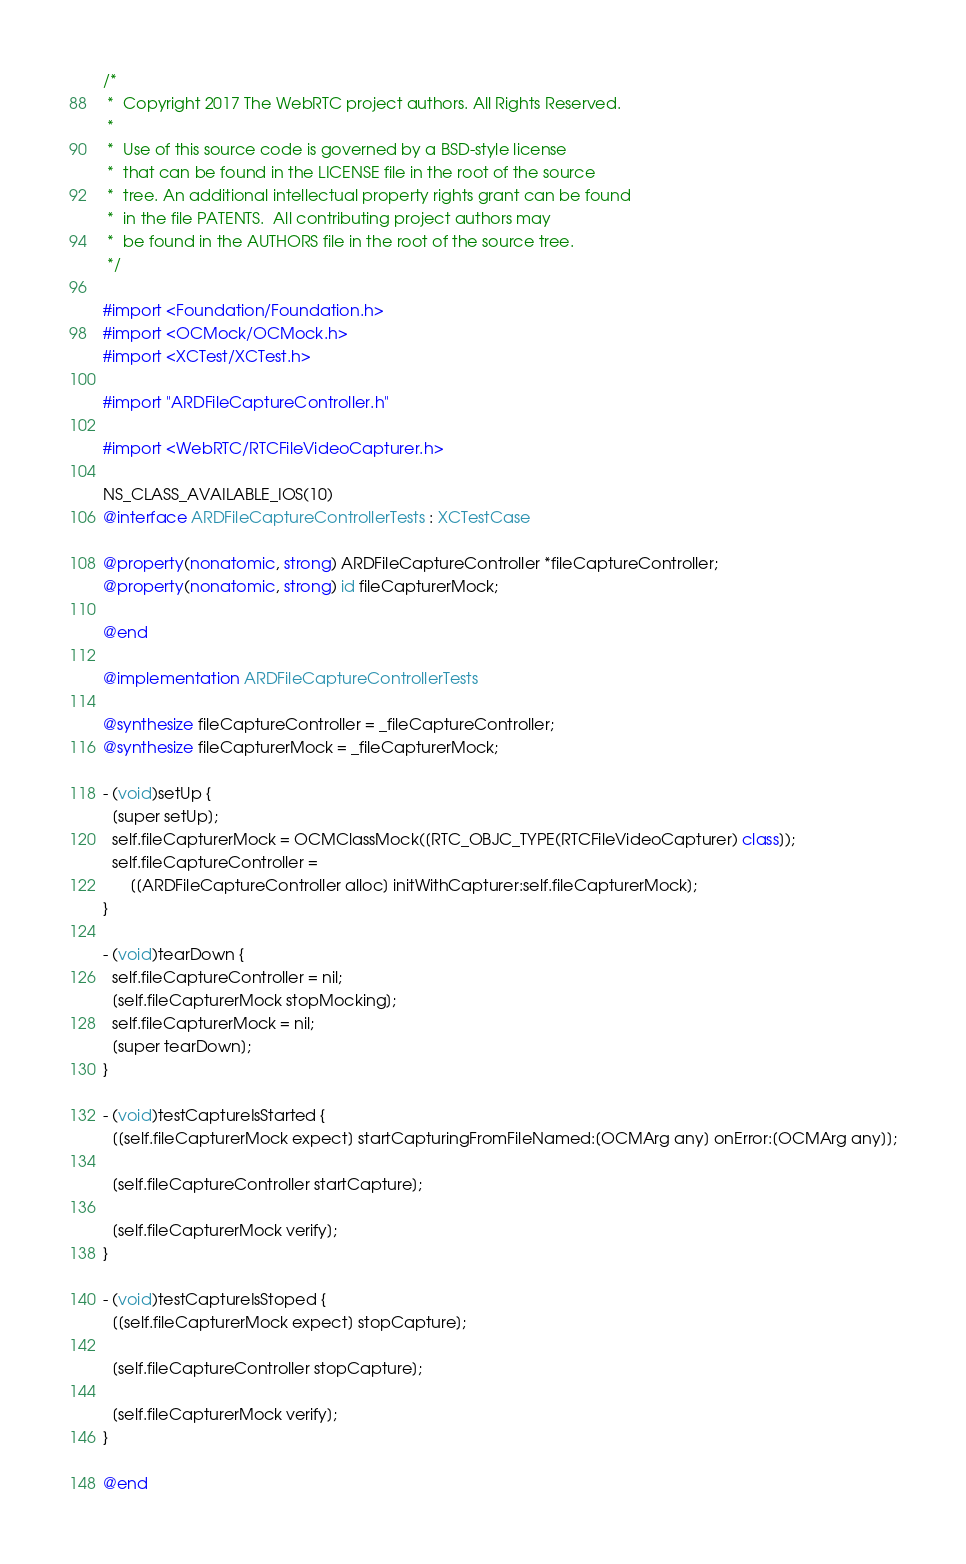Convert code to text. <code><loc_0><loc_0><loc_500><loc_500><_ObjectiveC_>/*
 *  Copyright 2017 The WebRTC project authors. All Rights Reserved.
 *
 *  Use of this source code is governed by a BSD-style license
 *  that can be found in the LICENSE file in the root of the source
 *  tree. An additional intellectual property rights grant can be found
 *  in the file PATENTS.  All contributing project authors may
 *  be found in the AUTHORS file in the root of the source tree.
 */

#import <Foundation/Foundation.h>
#import <OCMock/OCMock.h>
#import <XCTest/XCTest.h>

#import "ARDFileCaptureController.h"

#import <WebRTC/RTCFileVideoCapturer.h>

NS_CLASS_AVAILABLE_IOS(10)
@interface ARDFileCaptureControllerTests : XCTestCase

@property(nonatomic, strong) ARDFileCaptureController *fileCaptureController;
@property(nonatomic, strong) id fileCapturerMock;

@end

@implementation ARDFileCaptureControllerTests

@synthesize fileCaptureController = _fileCaptureController;
@synthesize fileCapturerMock = _fileCapturerMock;

- (void)setUp {
  [super setUp];
  self.fileCapturerMock = OCMClassMock([RTC_OBJC_TYPE(RTCFileVideoCapturer) class]);
  self.fileCaptureController =
      [[ARDFileCaptureController alloc] initWithCapturer:self.fileCapturerMock];
}

- (void)tearDown {
  self.fileCaptureController = nil;
  [self.fileCapturerMock stopMocking];
  self.fileCapturerMock = nil;
  [super tearDown];
}

- (void)testCaptureIsStarted {
  [[self.fileCapturerMock expect] startCapturingFromFileNamed:[OCMArg any] onError:[OCMArg any]];

  [self.fileCaptureController startCapture];

  [self.fileCapturerMock verify];
}

- (void)testCaptureIsStoped {
  [[self.fileCapturerMock expect] stopCapture];

  [self.fileCaptureController stopCapture];

  [self.fileCapturerMock verify];
}

@end
</code> 